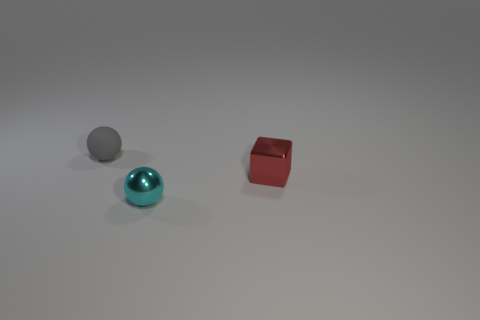Subtract all gray balls. How many balls are left? 1 Subtract all green spheres. Subtract all blue cylinders. How many spheres are left? 2 Add 3 big spheres. How many objects exist? 6 Subtract 1 red cubes. How many objects are left? 2 Subtract all balls. How many objects are left? 1 Subtract all brown cylinders. How many purple cubes are left? 0 Subtract all cyan rubber objects. Subtract all tiny matte objects. How many objects are left? 2 Add 3 small red metal cubes. How many small red metal cubes are left? 4 Add 3 small blocks. How many small blocks exist? 4 